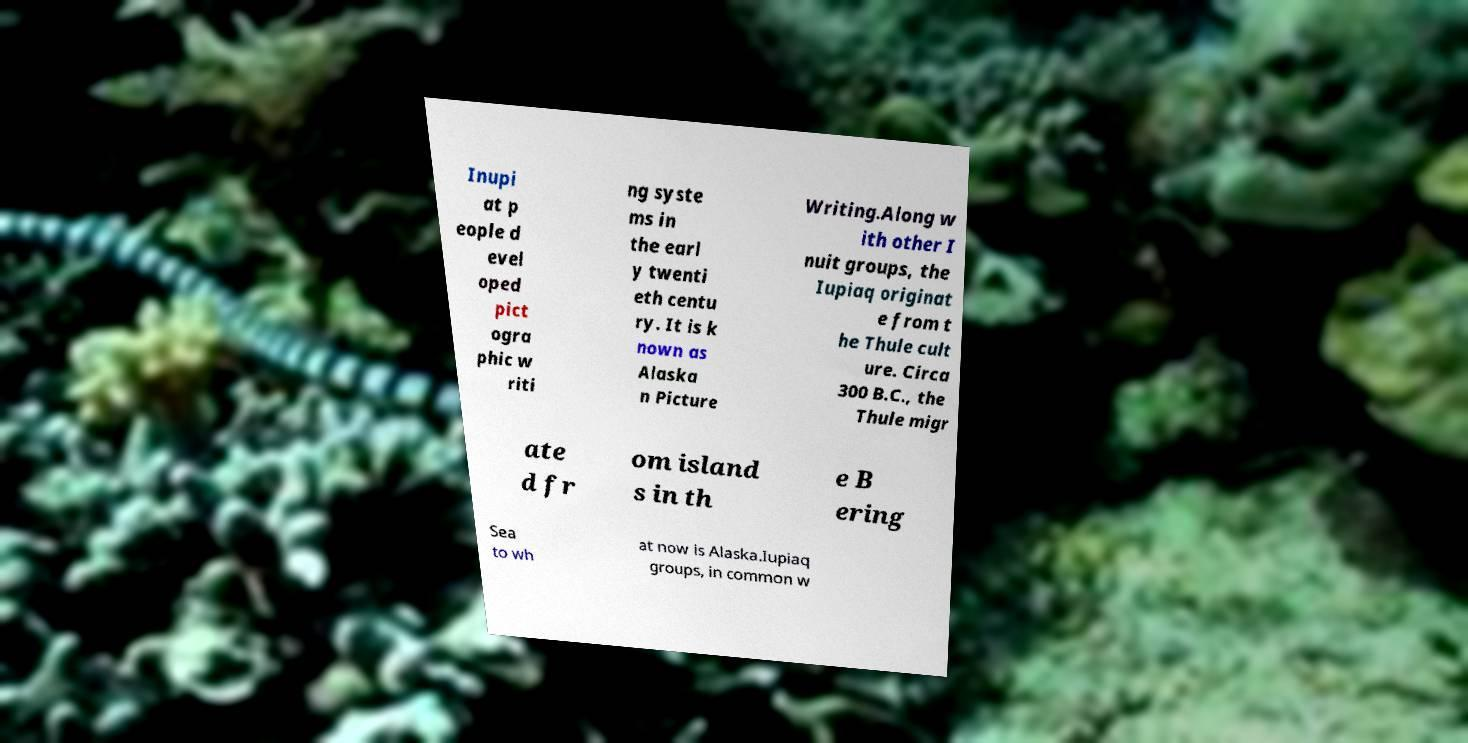Can you read and provide the text displayed in the image?This photo seems to have some interesting text. Can you extract and type it out for me? Inupi at p eople d evel oped pict ogra phic w riti ng syste ms in the earl y twenti eth centu ry. It is k nown as Alaska n Picture Writing.Along w ith other I nuit groups, the Iupiaq originat e from t he Thule cult ure. Circa 300 B.C., the Thule migr ate d fr om island s in th e B ering Sea to wh at now is Alaska.Iupiaq groups, in common w 